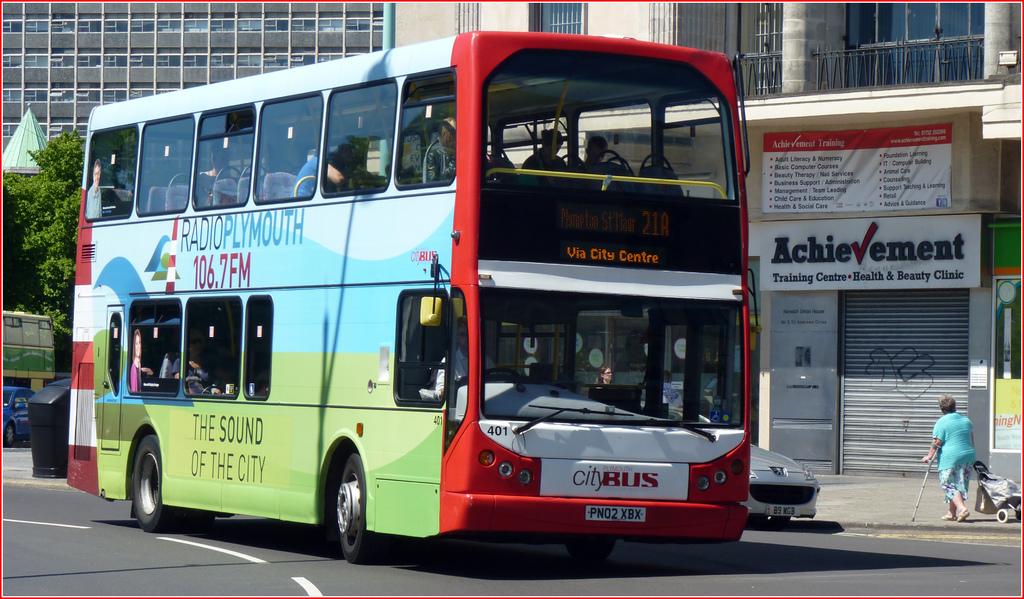Which radio station is the "sound of the city"?
Give a very brief answer. 106.7fm. 